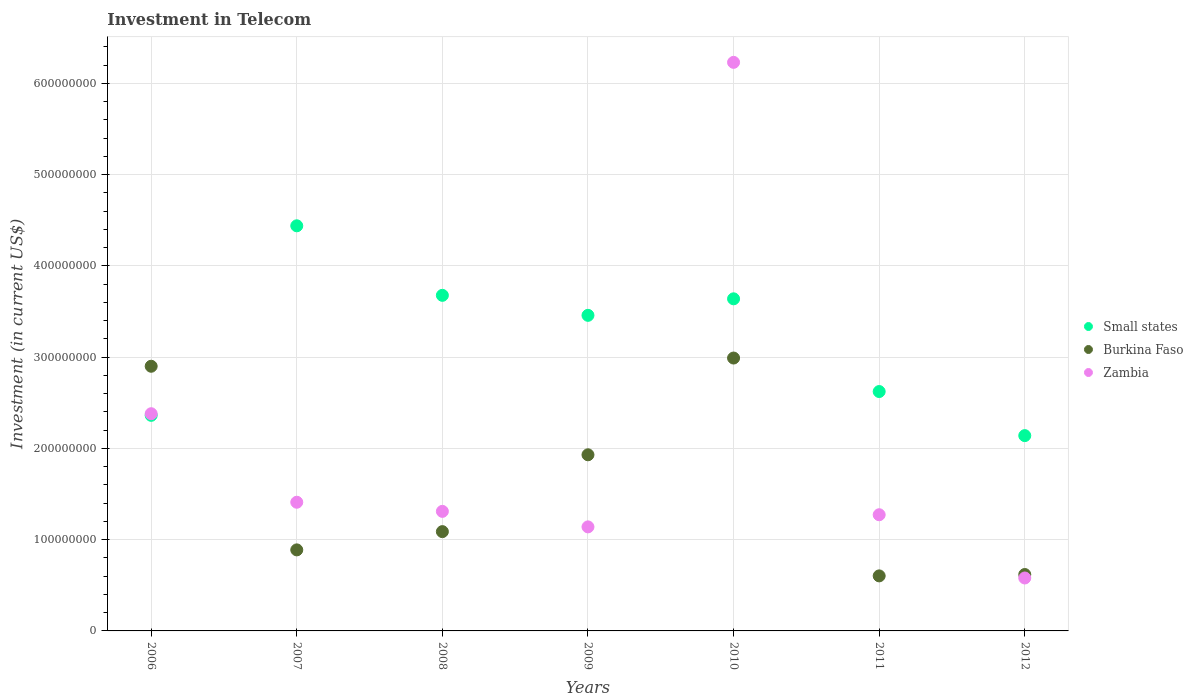How many different coloured dotlines are there?
Your answer should be compact. 3. What is the amount invested in telecom in Small states in 2009?
Ensure brevity in your answer.  3.46e+08. Across all years, what is the maximum amount invested in telecom in Zambia?
Your answer should be very brief. 6.23e+08. Across all years, what is the minimum amount invested in telecom in Zambia?
Offer a terse response. 5.80e+07. In which year was the amount invested in telecom in Zambia maximum?
Offer a terse response. 2010. What is the total amount invested in telecom in Burkina Faso in the graph?
Your response must be concise. 1.10e+09. What is the difference between the amount invested in telecom in Zambia in 2011 and that in 2012?
Your response must be concise. 6.93e+07. What is the difference between the amount invested in telecom in Zambia in 2012 and the amount invested in telecom in Small states in 2007?
Your answer should be very brief. -3.86e+08. What is the average amount invested in telecom in Burkina Faso per year?
Make the answer very short. 1.57e+08. In the year 2012, what is the difference between the amount invested in telecom in Zambia and amount invested in telecom in Burkina Faso?
Offer a terse response. -3.80e+06. In how many years, is the amount invested in telecom in Zambia greater than 220000000 US$?
Give a very brief answer. 2. What is the ratio of the amount invested in telecom in Small states in 2006 to that in 2012?
Keep it short and to the point. 1.1. Is the amount invested in telecom in Burkina Faso in 2011 less than that in 2012?
Give a very brief answer. Yes. What is the difference between the highest and the second highest amount invested in telecom in Burkina Faso?
Give a very brief answer. 9.00e+06. What is the difference between the highest and the lowest amount invested in telecom in Zambia?
Provide a succinct answer. 5.65e+08. In how many years, is the amount invested in telecom in Small states greater than the average amount invested in telecom in Small states taken over all years?
Your response must be concise. 4. Is it the case that in every year, the sum of the amount invested in telecom in Zambia and amount invested in telecom in Small states  is greater than the amount invested in telecom in Burkina Faso?
Offer a very short reply. Yes. Does the amount invested in telecom in Small states monotonically increase over the years?
Keep it short and to the point. No. Is the amount invested in telecom in Small states strictly greater than the amount invested in telecom in Zambia over the years?
Keep it short and to the point. No. How many dotlines are there?
Make the answer very short. 3. Are the values on the major ticks of Y-axis written in scientific E-notation?
Offer a very short reply. No. Does the graph contain any zero values?
Your response must be concise. No. Does the graph contain grids?
Your response must be concise. Yes. Where does the legend appear in the graph?
Your answer should be compact. Center right. What is the title of the graph?
Keep it short and to the point. Investment in Telecom. What is the label or title of the Y-axis?
Offer a very short reply. Investment (in current US$). What is the Investment (in current US$) of Small states in 2006?
Your response must be concise. 2.36e+08. What is the Investment (in current US$) of Burkina Faso in 2006?
Ensure brevity in your answer.  2.90e+08. What is the Investment (in current US$) of Zambia in 2006?
Offer a terse response. 2.38e+08. What is the Investment (in current US$) in Small states in 2007?
Your answer should be very brief. 4.44e+08. What is the Investment (in current US$) of Burkina Faso in 2007?
Your answer should be compact. 8.88e+07. What is the Investment (in current US$) of Zambia in 2007?
Offer a very short reply. 1.41e+08. What is the Investment (in current US$) of Small states in 2008?
Your answer should be compact. 3.68e+08. What is the Investment (in current US$) in Burkina Faso in 2008?
Your response must be concise. 1.09e+08. What is the Investment (in current US$) of Zambia in 2008?
Ensure brevity in your answer.  1.31e+08. What is the Investment (in current US$) in Small states in 2009?
Keep it short and to the point. 3.46e+08. What is the Investment (in current US$) in Burkina Faso in 2009?
Keep it short and to the point. 1.93e+08. What is the Investment (in current US$) in Zambia in 2009?
Your answer should be very brief. 1.14e+08. What is the Investment (in current US$) of Small states in 2010?
Make the answer very short. 3.64e+08. What is the Investment (in current US$) of Burkina Faso in 2010?
Offer a very short reply. 2.99e+08. What is the Investment (in current US$) in Zambia in 2010?
Ensure brevity in your answer.  6.23e+08. What is the Investment (in current US$) of Small states in 2011?
Give a very brief answer. 2.62e+08. What is the Investment (in current US$) in Burkina Faso in 2011?
Give a very brief answer. 6.03e+07. What is the Investment (in current US$) of Zambia in 2011?
Provide a short and direct response. 1.27e+08. What is the Investment (in current US$) of Small states in 2012?
Your answer should be compact. 2.14e+08. What is the Investment (in current US$) of Burkina Faso in 2012?
Provide a succinct answer. 6.18e+07. What is the Investment (in current US$) of Zambia in 2012?
Your answer should be compact. 5.80e+07. Across all years, what is the maximum Investment (in current US$) in Small states?
Your response must be concise. 4.44e+08. Across all years, what is the maximum Investment (in current US$) of Burkina Faso?
Ensure brevity in your answer.  2.99e+08. Across all years, what is the maximum Investment (in current US$) of Zambia?
Your answer should be compact. 6.23e+08. Across all years, what is the minimum Investment (in current US$) of Small states?
Ensure brevity in your answer.  2.14e+08. Across all years, what is the minimum Investment (in current US$) in Burkina Faso?
Provide a short and direct response. 6.03e+07. Across all years, what is the minimum Investment (in current US$) in Zambia?
Ensure brevity in your answer.  5.80e+07. What is the total Investment (in current US$) in Small states in the graph?
Provide a short and direct response. 2.23e+09. What is the total Investment (in current US$) of Burkina Faso in the graph?
Give a very brief answer. 1.10e+09. What is the total Investment (in current US$) of Zambia in the graph?
Provide a short and direct response. 1.43e+09. What is the difference between the Investment (in current US$) in Small states in 2006 and that in 2007?
Ensure brevity in your answer.  -2.08e+08. What is the difference between the Investment (in current US$) of Burkina Faso in 2006 and that in 2007?
Your response must be concise. 2.01e+08. What is the difference between the Investment (in current US$) in Zambia in 2006 and that in 2007?
Your answer should be very brief. 9.70e+07. What is the difference between the Investment (in current US$) of Small states in 2006 and that in 2008?
Offer a terse response. -1.31e+08. What is the difference between the Investment (in current US$) in Burkina Faso in 2006 and that in 2008?
Keep it short and to the point. 1.81e+08. What is the difference between the Investment (in current US$) in Zambia in 2006 and that in 2008?
Ensure brevity in your answer.  1.07e+08. What is the difference between the Investment (in current US$) in Small states in 2006 and that in 2009?
Offer a terse response. -1.10e+08. What is the difference between the Investment (in current US$) in Burkina Faso in 2006 and that in 2009?
Offer a very short reply. 9.70e+07. What is the difference between the Investment (in current US$) in Zambia in 2006 and that in 2009?
Your answer should be very brief. 1.24e+08. What is the difference between the Investment (in current US$) in Small states in 2006 and that in 2010?
Make the answer very short. -1.28e+08. What is the difference between the Investment (in current US$) of Burkina Faso in 2006 and that in 2010?
Provide a short and direct response. -9.00e+06. What is the difference between the Investment (in current US$) in Zambia in 2006 and that in 2010?
Provide a succinct answer. -3.85e+08. What is the difference between the Investment (in current US$) of Small states in 2006 and that in 2011?
Provide a short and direct response. -2.61e+07. What is the difference between the Investment (in current US$) of Burkina Faso in 2006 and that in 2011?
Give a very brief answer. 2.30e+08. What is the difference between the Investment (in current US$) in Zambia in 2006 and that in 2011?
Offer a very short reply. 1.11e+08. What is the difference between the Investment (in current US$) in Small states in 2006 and that in 2012?
Ensure brevity in your answer.  2.22e+07. What is the difference between the Investment (in current US$) of Burkina Faso in 2006 and that in 2012?
Offer a very short reply. 2.28e+08. What is the difference between the Investment (in current US$) in Zambia in 2006 and that in 2012?
Provide a short and direct response. 1.80e+08. What is the difference between the Investment (in current US$) in Small states in 2007 and that in 2008?
Ensure brevity in your answer.  7.62e+07. What is the difference between the Investment (in current US$) of Burkina Faso in 2007 and that in 2008?
Ensure brevity in your answer.  -2.00e+07. What is the difference between the Investment (in current US$) of Small states in 2007 and that in 2009?
Your response must be concise. 9.81e+07. What is the difference between the Investment (in current US$) in Burkina Faso in 2007 and that in 2009?
Make the answer very short. -1.04e+08. What is the difference between the Investment (in current US$) in Zambia in 2007 and that in 2009?
Ensure brevity in your answer.  2.70e+07. What is the difference between the Investment (in current US$) of Small states in 2007 and that in 2010?
Your response must be concise. 8.00e+07. What is the difference between the Investment (in current US$) of Burkina Faso in 2007 and that in 2010?
Ensure brevity in your answer.  -2.10e+08. What is the difference between the Investment (in current US$) of Zambia in 2007 and that in 2010?
Make the answer very short. -4.82e+08. What is the difference between the Investment (in current US$) in Small states in 2007 and that in 2011?
Provide a short and direct response. 1.82e+08. What is the difference between the Investment (in current US$) in Burkina Faso in 2007 and that in 2011?
Make the answer very short. 2.85e+07. What is the difference between the Investment (in current US$) in Zambia in 2007 and that in 2011?
Offer a terse response. 1.37e+07. What is the difference between the Investment (in current US$) in Small states in 2007 and that in 2012?
Provide a succinct answer. 2.30e+08. What is the difference between the Investment (in current US$) in Burkina Faso in 2007 and that in 2012?
Keep it short and to the point. 2.70e+07. What is the difference between the Investment (in current US$) of Zambia in 2007 and that in 2012?
Offer a terse response. 8.30e+07. What is the difference between the Investment (in current US$) of Small states in 2008 and that in 2009?
Provide a short and direct response. 2.19e+07. What is the difference between the Investment (in current US$) in Burkina Faso in 2008 and that in 2009?
Keep it short and to the point. -8.42e+07. What is the difference between the Investment (in current US$) in Zambia in 2008 and that in 2009?
Offer a very short reply. 1.70e+07. What is the difference between the Investment (in current US$) in Small states in 2008 and that in 2010?
Keep it short and to the point. 3.81e+06. What is the difference between the Investment (in current US$) in Burkina Faso in 2008 and that in 2010?
Your answer should be compact. -1.90e+08. What is the difference between the Investment (in current US$) in Zambia in 2008 and that in 2010?
Ensure brevity in your answer.  -4.92e+08. What is the difference between the Investment (in current US$) in Small states in 2008 and that in 2011?
Your answer should be very brief. 1.05e+08. What is the difference between the Investment (in current US$) of Burkina Faso in 2008 and that in 2011?
Offer a very short reply. 4.85e+07. What is the difference between the Investment (in current US$) in Zambia in 2008 and that in 2011?
Give a very brief answer. 3.70e+06. What is the difference between the Investment (in current US$) of Small states in 2008 and that in 2012?
Your answer should be very brief. 1.54e+08. What is the difference between the Investment (in current US$) of Burkina Faso in 2008 and that in 2012?
Give a very brief answer. 4.70e+07. What is the difference between the Investment (in current US$) in Zambia in 2008 and that in 2012?
Make the answer very short. 7.30e+07. What is the difference between the Investment (in current US$) in Small states in 2009 and that in 2010?
Keep it short and to the point. -1.81e+07. What is the difference between the Investment (in current US$) of Burkina Faso in 2009 and that in 2010?
Ensure brevity in your answer.  -1.06e+08. What is the difference between the Investment (in current US$) of Zambia in 2009 and that in 2010?
Provide a succinct answer. -5.09e+08. What is the difference between the Investment (in current US$) of Small states in 2009 and that in 2011?
Provide a succinct answer. 8.35e+07. What is the difference between the Investment (in current US$) in Burkina Faso in 2009 and that in 2011?
Your response must be concise. 1.33e+08. What is the difference between the Investment (in current US$) in Zambia in 2009 and that in 2011?
Your response must be concise. -1.33e+07. What is the difference between the Investment (in current US$) of Small states in 2009 and that in 2012?
Give a very brief answer. 1.32e+08. What is the difference between the Investment (in current US$) in Burkina Faso in 2009 and that in 2012?
Your answer should be very brief. 1.31e+08. What is the difference between the Investment (in current US$) in Zambia in 2009 and that in 2012?
Ensure brevity in your answer.  5.60e+07. What is the difference between the Investment (in current US$) in Small states in 2010 and that in 2011?
Offer a very short reply. 1.02e+08. What is the difference between the Investment (in current US$) of Burkina Faso in 2010 and that in 2011?
Your response must be concise. 2.39e+08. What is the difference between the Investment (in current US$) of Zambia in 2010 and that in 2011?
Ensure brevity in your answer.  4.96e+08. What is the difference between the Investment (in current US$) of Small states in 2010 and that in 2012?
Provide a short and direct response. 1.50e+08. What is the difference between the Investment (in current US$) in Burkina Faso in 2010 and that in 2012?
Provide a succinct answer. 2.37e+08. What is the difference between the Investment (in current US$) of Zambia in 2010 and that in 2012?
Make the answer very short. 5.65e+08. What is the difference between the Investment (in current US$) of Small states in 2011 and that in 2012?
Your response must be concise. 4.83e+07. What is the difference between the Investment (in current US$) in Burkina Faso in 2011 and that in 2012?
Your answer should be very brief. -1.50e+06. What is the difference between the Investment (in current US$) in Zambia in 2011 and that in 2012?
Provide a short and direct response. 6.93e+07. What is the difference between the Investment (in current US$) in Small states in 2006 and the Investment (in current US$) in Burkina Faso in 2007?
Provide a succinct answer. 1.47e+08. What is the difference between the Investment (in current US$) in Small states in 2006 and the Investment (in current US$) in Zambia in 2007?
Provide a short and direct response. 9.52e+07. What is the difference between the Investment (in current US$) in Burkina Faso in 2006 and the Investment (in current US$) in Zambia in 2007?
Give a very brief answer. 1.49e+08. What is the difference between the Investment (in current US$) of Small states in 2006 and the Investment (in current US$) of Burkina Faso in 2008?
Ensure brevity in your answer.  1.27e+08. What is the difference between the Investment (in current US$) of Small states in 2006 and the Investment (in current US$) of Zambia in 2008?
Offer a very short reply. 1.05e+08. What is the difference between the Investment (in current US$) in Burkina Faso in 2006 and the Investment (in current US$) in Zambia in 2008?
Your answer should be very brief. 1.59e+08. What is the difference between the Investment (in current US$) in Small states in 2006 and the Investment (in current US$) in Burkina Faso in 2009?
Provide a succinct answer. 4.32e+07. What is the difference between the Investment (in current US$) in Small states in 2006 and the Investment (in current US$) in Zambia in 2009?
Give a very brief answer. 1.22e+08. What is the difference between the Investment (in current US$) of Burkina Faso in 2006 and the Investment (in current US$) of Zambia in 2009?
Give a very brief answer. 1.76e+08. What is the difference between the Investment (in current US$) of Small states in 2006 and the Investment (in current US$) of Burkina Faso in 2010?
Offer a very short reply. -6.28e+07. What is the difference between the Investment (in current US$) of Small states in 2006 and the Investment (in current US$) of Zambia in 2010?
Your answer should be very brief. -3.87e+08. What is the difference between the Investment (in current US$) in Burkina Faso in 2006 and the Investment (in current US$) in Zambia in 2010?
Offer a very short reply. -3.33e+08. What is the difference between the Investment (in current US$) of Small states in 2006 and the Investment (in current US$) of Burkina Faso in 2011?
Provide a short and direct response. 1.76e+08. What is the difference between the Investment (in current US$) of Small states in 2006 and the Investment (in current US$) of Zambia in 2011?
Offer a very short reply. 1.09e+08. What is the difference between the Investment (in current US$) in Burkina Faso in 2006 and the Investment (in current US$) in Zambia in 2011?
Provide a succinct answer. 1.63e+08. What is the difference between the Investment (in current US$) of Small states in 2006 and the Investment (in current US$) of Burkina Faso in 2012?
Your response must be concise. 1.74e+08. What is the difference between the Investment (in current US$) in Small states in 2006 and the Investment (in current US$) in Zambia in 2012?
Keep it short and to the point. 1.78e+08. What is the difference between the Investment (in current US$) in Burkina Faso in 2006 and the Investment (in current US$) in Zambia in 2012?
Make the answer very short. 2.32e+08. What is the difference between the Investment (in current US$) in Small states in 2007 and the Investment (in current US$) in Burkina Faso in 2008?
Your response must be concise. 3.35e+08. What is the difference between the Investment (in current US$) of Small states in 2007 and the Investment (in current US$) of Zambia in 2008?
Provide a succinct answer. 3.13e+08. What is the difference between the Investment (in current US$) of Burkina Faso in 2007 and the Investment (in current US$) of Zambia in 2008?
Keep it short and to the point. -4.22e+07. What is the difference between the Investment (in current US$) in Small states in 2007 and the Investment (in current US$) in Burkina Faso in 2009?
Give a very brief answer. 2.51e+08. What is the difference between the Investment (in current US$) of Small states in 2007 and the Investment (in current US$) of Zambia in 2009?
Make the answer very short. 3.30e+08. What is the difference between the Investment (in current US$) in Burkina Faso in 2007 and the Investment (in current US$) in Zambia in 2009?
Keep it short and to the point. -2.52e+07. What is the difference between the Investment (in current US$) of Small states in 2007 and the Investment (in current US$) of Burkina Faso in 2010?
Your response must be concise. 1.45e+08. What is the difference between the Investment (in current US$) in Small states in 2007 and the Investment (in current US$) in Zambia in 2010?
Offer a very short reply. -1.79e+08. What is the difference between the Investment (in current US$) of Burkina Faso in 2007 and the Investment (in current US$) of Zambia in 2010?
Keep it short and to the point. -5.34e+08. What is the difference between the Investment (in current US$) in Small states in 2007 and the Investment (in current US$) in Burkina Faso in 2011?
Keep it short and to the point. 3.84e+08. What is the difference between the Investment (in current US$) of Small states in 2007 and the Investment (in current US$) of Zambia in 2011?
Keep it short and to the point. 3.17e+08. What is the difference between the Investment (in current US$) of Burkina Faso in 2007 and the Investment (in current US$) of Zambia in 2011?
Provide a succinct answer. -3.85e+07. What is the difference between the Investment (in current US$) of Small states in 2007 and the Investment (in current US$) of Burkina Faso in 2012?
Provide a short and direct response. 3.82e+08. What is the difference between the Investment (in current US$) in Small states in 2007 and the Investment (in current US$) in Zambia in 2012?
Provide a short and direct response. 3.86e+08. What is the difference between the Investment (in current US$) in Burkina Faso in 2007 and the Investment (in current US$) in Zambia in 2012?
Your response must be concise. 3.08e+07. What is the difference between the Investment (in current US$) in Small states in 2008 and the Investment (in current US$) in Burkina Faso in 2009?
Your answer should be very brief. 1.75e+08. What is the difference between the Investment (in current US$) of Small states in 2008 and the Investment (in current US$) of Zambia in 2009?
Provide a succinct answer. 2.54e+08. What is the difference between the Investment (in current US$) in Burkina Faso in 2008 and the Investment (in current US$) in Zambia in 2009?
Offer a terse response. -5.20e+06. What is the difference between the Investment (in current US$) of Small states in 2008 and the Investment (in current US$) of Burkina Faso in 2010?
Your answer should be very brief. 6.87e+07. What is the difference between the Investment (in current US$) in Small states in 2008 and the Investment (in current US$) in Zambia in 2010?
Your answer should be compact. -2.55e+08. What is the difference between the Investment (in current US$) in Burkina Faso in 2008 and the Investment (in current US$) in Zambia in 2010?
Your answer should be very brief. -5.14e+08. What is the difference between the Investment (in current US$) in Small states in 2008 and the Investment (in current US$) in Burkina Faso in 2011?
Your answer should be very brief. 3.07e+08. What is the difference between the Investment (in current US$) in Small states in 2008 and the Investment (in current US$) in Zambia in 2011?
Offer a very short reply. 2.40e+08. What is the difference between the Investment (in current US$) in Burkina Faso in 2008 and the Investment (in current US$) in Zambia in 2011?
Keep it short and to the point. -1.85e+07. What is the difference between the Investment (in current US$) in Small states in 2008 and the Investment (in current US$) in Burkina Faso in 2012?
Provide a short and direct response. 3.06e+08. What is the difference between the Investment (in current US$) of Small states in 2008 and the Investment (in current US$) of Zambia in 2012?
Your answer should be very brief. 3.10e+08. What is the difference between the Investment (in current US$) in Burkina Faso in 2008 and the Investment (in current US$) in Zambia in 2012?
Your response must be concise. 5.08e+07. What is the difference between the Investment (in current US$) of Small states in 2009 and the Investment (in current US$) of Burkina Faso in 2010?
Give a very brief answer. 4.68e+07. What is the difference between the Investment (in current US$) of Small states in 2009 and the Investment (in current US$) of Zambia in 2010?
Offer a terse response. -2.77e+08. What is the difference between the Investment (in current US$) of Burkina Faso in 2009 and the Investment (in current US$) of Zambia in 2010?
Make the answer very short. -4.30e+08. What is the difference between the Investment (in current US$) in Small states in 2009 and the Investment (in current US$) in Burkina Faso in 2011?
Your answer should be very brief. 2.86e+08. What is the difference between the Investment (in current US$) of Small states in 2009 and the Investment (in current US$) of Zambia in 2011?
Keep it short and to the point. 2.18e+08. What is the difference between the Investment (in current US$) of Burkina Faso in 2009 and the Investment (in current US$) of Zambia in 2011?
Give a very brief answer. 6.57e+07. What is the difference between the Investment (in current US$) in Small states in 2009 and the Investment (in current US$) in Burkina Faso in 2012?
Your answer should be compact. 2.84e+08. What is the difference between the Investment (in current US$) of Small states in 2009 and the Investment (in current US$) of Zambia in 2012?
Provide a short and direct response. 2.88e+08. What is the difference between the Investment (in current US$) of Burkina Faso in 2009 and the Investment (in current US$) of Zambia in 2012?
Your response must be concise. 1.35e+08. What is the difference between the Investment (in current US$) in Small states in 2010 and the Investment (in current US$) in Burkina Faso in 2011?
Ensure brevity in your answer.  3.04e+08. What is the difference between the Investment (in current US$) of Small states in 2010 and the Investment (in current US$) of Zambia in 2011?
Offer a very short reply. 2.37e+08. What is the difference between the Investment (in current US$) in Burkina Faso in 2010 and the Investment (in current US$) in Zambia in 2011?
Keep it short and to the point. 1.72e+08. What is the difference between the Investment (in current US$) of Small states in 2010 and the Investment (in current US$) of Burkina Faso in 2012?
Your answer should be compact. 3.02e+08. What is the difference between the Investment (in current US$) of Small states in 2010 and the Investment (in current US$) of Zambia in 2012?
Provide a short and direct response. 3.06e+08. What is the difference between the Investment (in current US$) in Burkina Faso in 2010 and the Investment (in current US$) in Zambia in 2012?
Your answer should be compact. 2.41e+08. What is the difference between the Investment (in current US$) of Small states in 2011 and the Investment (in current US$) of Burkina Faso in 2012?
Provide a succinct answer. 2.00e+08. What is the difference between the Investment (in current US$) of Small states in 2011 and the Investment (in current US$) of Zambia in 2012?
Make the answer very short. 2.04e+08. What is the difference between the Investment (in current US$) of Burkina Faso in 2011 and the Investment (in current US$) of Zambia in 2012?
Your answer should be compact. 2.30e+06. What is the average Investment (in current US$) of Small states per year?
Your answer should be compact. 3.19e+08. What is the average Investment (in current US$) in Burkina Faso per year?
Ensure brevity in your answer.  1.57e+08. What is the average Investment (in current US$) of Zambia per year?
Offer a very short reply. 2.05e+08. In the year 2006, what is the difference between the Investment (in current US$) in Small states and Investment (in current US$) in Burkina Faso?
Give a very brief answer. -5.38e+07. In the year 2006, what is the difference between the Investment (in current US$) in Small states and Investment (in current US$) in Zambia?
Your answer should be compact. -1.77e+06. In the year 2006, what is the difference between the Investment (in current US$) in Burkina Faso and Investment (in current US$) in Zambia?
Ensure brevity in your answer.  5.20e+07. In the year 2007, what is the difference between the Investment (in current US$) of Small states and Investment (in current US$) of Burkina Faso?
Give a very brief answer. 3.55e+08. In the year 2007, what is the difference between the Investment (in current US$) of Small states and Investment (in current US$) of Zambia?
Give a very brief answer. 3.03e+08. In the year 2007, what is the difference between the Investment (in current US$) in Burkina Faso and Investment (in current US$) in Zambia?
Your answer should be compact. -5.22e+07. In the year 2008, what is the difference between the Investment (in current US$) in Small states and Investment (in current US$) in Burkina Faso?
Your response must be concise. 2.59e+08. In the year 2008, what is the difference between the Investment (in current US$) in Small states and Investment (in current US$) in Zambia?
Provide a succinct answer. 2.37e+08. In the year 2008, what is the difference between the Investment (in current US$) in Burkina Faso and Investment (in current US$) in Zambia?
Offer a terse response. -2.22e+07. In the year 2009, what is the difference between the Investment (in current US$) of Small states and Investment (in current US$) of Burkina Faso?
Offer a terse response. 1.53e+08. In the year 2009, what is the difference between the Investment (in current US$) in Small states and Investment (in current US$) in Zambia?
Provide a short and direct response. 2.32e+08. In the year 2009, what is the difference between the Investment (in current US$) in Burkina Faso and Investment (in current US$) in Zambia?
Ensure brevity in your answer.  7.90e+07. In the year 2010, what is the difference between the Investment (in current US$) in Small states and Investment (in current US$) in Burkina Faso?
Make the answer very short. 6.49e+07. In the year 2010, what is the difference between the Investment (in current US$) of Small states and Investment (in current US$) of Zambia?
Offer a terse response. -2.59e+08. In the year 2010, what is the difference between the Investment (in current US$) in Burkina Faso and Investment (in current US$) in Zambia?
Your answer should be compact. -3.24e+08. In the year 2011, what is the difference between the Investment (in current US$) in Small states and Investment (in current US$) in Burkina Faso?
Provide a short and direct response. 2.02e+08. In the year 2011, what is the difference between the Investment (in current US$) of Small states and Investment (in current US$) of Zambia?
Make the answer very short. 1.35e+08. In the year 2011, what is the difference between the Investment (in current US$) in Burkina Faso and Investment (in current US$) in Zambia?
Offer a terse response. -6.70e+07. In the year 2012, what is the difference between the Investment (in current US$) of Small states and Investment (in current US$) of Burkina Faso?
Your answer should be compact. 1.52e+08. In the year 2012, what is the difference between the Investment (in current US$) in Small states and Investment (in current US$) in Zambia?
Provide a short and direct response. 1.56e+08. In the year 2012, what is the difference between the Investment (in current US$) of Burkina Faso and Investment (in current US$) of Zambia?
Make the answer very short. 3.80e+06. What is the ratio of the Investment (in current US$) of Small states in 2006 to that in 2007?
Make the answer very short. 0.53. What is the ratio of the Investment (in current US$) in Burkina Faso in 2006 to that in 2007?
Your response must be concise. 3.27. What is the ratio of the Investment (in current US$) in Zambia in 2006 to that in 2007?
Keep it short and to the point. 1.69. What is the ratio of the Investment (in current US$) of Small states in 2006 to that in 2008?
Offer a very short reply. 0.64. What is the ratio of the Investment (in current US$) of Burkina Faso in 2006 to that in 2008?
Your answer should be compact. 2.67. What is the ratio of the Investment (in current US$) of Zambia in 2006 to that in 2008?
Keep it short and to the point. 1.82. What is the ratio of the Investment (in current US$) of Small states in 2006 to that in 2009?
Offer a very short reply. 0.68. What is the ratio of the Investment (in current US$) in Burkina Faso in 2006 to that in 2009?
Keep it short and to the point. 1.5. What is the ratio of the Investment (in current US$) in Zambia in 2006 to that in 2009?
Your answer should be very brief. 2.09. What is the ratio of the Investment (in current US$) of Small states in 2006 to that in 2010?
Give a very brief answer. 0.65. What is the ratio of the Investment (in current US$) of Burkina Faso in 2006 to that in 2010?
Keep it short and to the point. 0.97. What is the ratio of the Investment (in current US$) of Zambia in 2006 to that in 2010?
Offer a terse response. 0.38. What is the ratio of the Investment (in current US$) of Small states in 2006 to that in 2011?
Provide a succinct answer. 0.9. What is the ratio of the Investment (in current US$) of Burkina Faso in 2006 to that in 2011?
Your answer should be compact. 4.81. What is the ratio of the Investment (in current US$) in Zambia in 2006 to that in 2011?
Make the answer very short. 1.87. What is the ratio of the Investment (in current US$) in Small states in 2006 to that in 2012?
Ensure brevity in your answer.  1.1. What is the ratio of the Investment (in current US$) in Burkina Faso in 2006 to that in 2012?
Provide a succinct answer. 4.69. What is the ratio of the Investment (in current US$) in Zambia in 2006 to that in 2012?
Offer a terse response. 4.1. What is the ratio of the Investment (in current US$) of Small states in 2007 to that in 2008?
Make the answer very short. 1.21. What is the ratio of the Investment (in current US$) of Burkina Faso in 2007 to that in 2008?
Offer a very short reply. 0.82. What is the ratio of the Investment (in current US$) in Zambia in 2007 to that in 2008?
Ensure brevity in your answer.  1.08. What is the ratio of the Investment (in current US$) of Small states in 2007 to that in 2009?
Offer a very short reply. 1.28. What is the ratio of the Investment (in current US$) in Burkina Faso in 2007 to that in 2009?
Provide a succinct answer. 0.46. What is the ratio of the Investment (in current US$) in Zambia in 2007 to that in 2009?
Keep it short and to the point. 1.24. What is the ratio of the Investment (in current US$) in Small states in 2007 to that in 2010?
Provide a succinct answer. 1.22. What is the ratio of the Investment (in current US$) in Burkina Faso in 2007 to that in 2010?
Provide a short and direct response. 0.3. What is the ratio of the Investment (in current US$) of Zambia in 2007 to that in 2010?
Give a very brief answer. 0.23. What is the ratio of the Investment (in current US$) of Small states in 2007 to that in 2011?
Your answer should be very brief. 1.69. What is the ratio of the Investment (in current US$) of Burkina Faso in 2007 to that in 2011?
Offer a very short reply. 1.47. What is the ratio of the Investment (in current US$) in Zambia in 2007 to that in 2011?
Offer a terse response. 1.11. What is the ratio of the Investment (in current US$) in Small states in 2007 to that in 2012?
Provide a short and direct response. 2.07. What is the ratio of the Investment (in current US$) in Burkina Faso in 2007 to that in 2012?
Ensure brevity in your answer.  1.44. What is the ratio of the Investment (in current US$) of Zambia in 2007 to that in 2012?
Give a very brief answer. 2.43. What is the ratio of the Investment (in current US$) of Small states in 2008 to that in 2009?
Provide a short and direct response. 1.06. What is the ratio of the Investment (in current US$) of Burkina Faso in 2008 to that in 2009?
Ensure brevity in your answer.  0.56. What is the ratio of the Investment (in current US$) of Zambia in 2008 to that in 2009?
Keep it short and to the point. 1.15. What is the ratio of the Investment (in current US$) of Small states in 2008 to that in 2010?
Keep it short and to the point. 1.01. What is the ratio of the Investment (in current US$) of Burkina Faso in 2008 to that in 2010?
Offer a terse response. 0.36. What is the ratio of the Investment (in current US$) of Zambia in 2008 to that in 2010?
Your answer should be very brief. 0.21. What is the ratio of the Investment (in current US$) in Small states in 2008 to that in 2011?
Give a very brief answer. 1.4. What is the ratio of the Investment (in current US$) in Burkina Faso in 2008 to that in 2011?
Your answer should be very brief. 1.8. What is the ratio of the Investment (in current US$) in Zambia in 2008 to that in 2011?
Your answer should be compact. 1.03. What is the ratio of the Investment (in current US$) in Small states in 2008 to that in 2012?
Ensure brevity in your answer.  1.72. What is the ratio of the Investment (in current US$) of Burkina Faso in 2008 to that in 2012?
Provide a short and direct response. 1.76. What is the ratio of the Investment (in current US$) of Zambia in 2008 to that in 2012?
Give a very brief answer. 2.26. What is the ratio of the Investment (in current US$) of Small states in 2009 to that in 2010?
Your answer should be very brief. 0.95. What is the ratio of the Investment (in current US$) of Burkina Faso in 2009 to that in 2010?
Your response must be concise. 0.65. What is the ratio of the Investment (in current US$) in Zambia in 2009 to that in 2010?
Give a very brief answer. 0.18. What is the ratio of the Investment (in current US$) of Small states in 2009 to that in 2011?
Keep it short and to the point. 1.32. What is the ratio of the Investment (in current US$) of Burkina Faso in 2009 to that in 2011?
Give a very brief answer. 3.2. What is the ratio of the Investment (in current US$) in Zambia in 2009 to that in 2011?
Your answer should be compact. 0.9. What is the ratio of the Investment (in current US$) of Small states in 2009 to that in 2012?
Make the answer very short. 1.62. What is the ratio of the Investment (in current US$) in Burkina Faso in 2009 to that in 2012?
Offer a very short reply. 3.12. What is the ratio of the Investment (in current US$) of Zambia in 2009 to that in 2012?
Provide a succinct answer. 1.97. What is the ratio of the Investment (in current US$) of Small states in 2010 to that in 2011?
Your response must be concise. 1.39. What is the ratio of the Investment (in current US$) of Burkina Faso in 2010 to that in 2011?
Provide a short and direct response. 4.96. What is the ratio of the Investment (in current US$) of Zambia in 2010 to that in 2011?
Ensure brevity in your answer.  4.89. What is the ratio of the Investment (in current US$) of Small states in 2010 to that in 2012?
Your answer should be very brief. 1.7. What is the ratio of the Investment (in current US$) of Burkina Faso in 2010 to that in 2012?
Provide a succinct answer. 4.84. What is the ratio of the Investment (in current US$) in Zambia in 2010 to that in 2012?
Make the answer very short. 10.74. What is the ratio of the Investment (in current US$) in Small states in 2011 to that in 2012?
Your answer should be very brief. 1.23. What is the ratio of the Investment (in current US$) of Burkina Faso in 2011 to that in 2012?
Your answer should be very brief. 0.98. What is the ratio of the Investment (in current US$) of Zambia in 2011 to that in 2012?
Your response must be concise. 2.19. What is the difference between the highest and the second highest Investment (in current US$) in Small states?
Give a very brief answer. 7.62e+07. What is the difference between the highest and the second highest Investment (in current US$) in Burkina Faso?
Give a very brief answer. 9.00e+06. What is the difference between the highest and the second highest Investment (in current US$) in Zambia?
Offer a very short reply. 3.85e+08. What is the difference between the highest and the lowest Investment (in current US$) in Small states?
Offer a very short reply. 2.30e+08. What is the difference between the highest and the lowest Investment (in current US$) of Burkina Faso?
Offer a terse response. 2.39e+08. What is the difference between the highest and the lowest Investment (in current US$) in Zambia?
Give a very brief answer. 5.65e+08. 